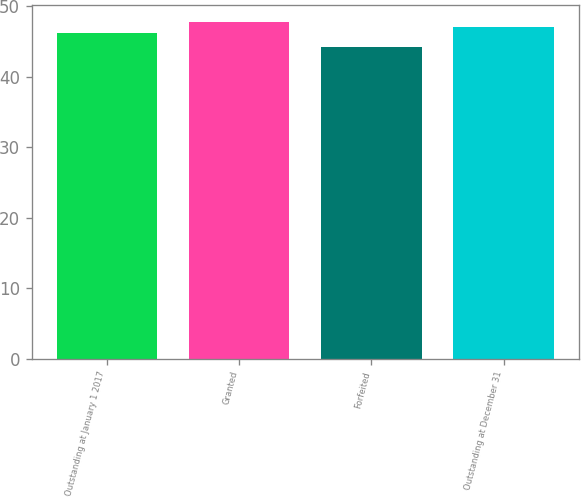Convert chart. <chart><loc_0><loc_0><loc_500><loc_500><bar_chart><fcel>Outstanding at January 1 2017<fcel>Granted<fcel>Forfeited<fcel>Outstanding at December 31<nl><fcel>46.15<fcel>47.79<fcel>44.19<fcel>47.04<nl></chart> 